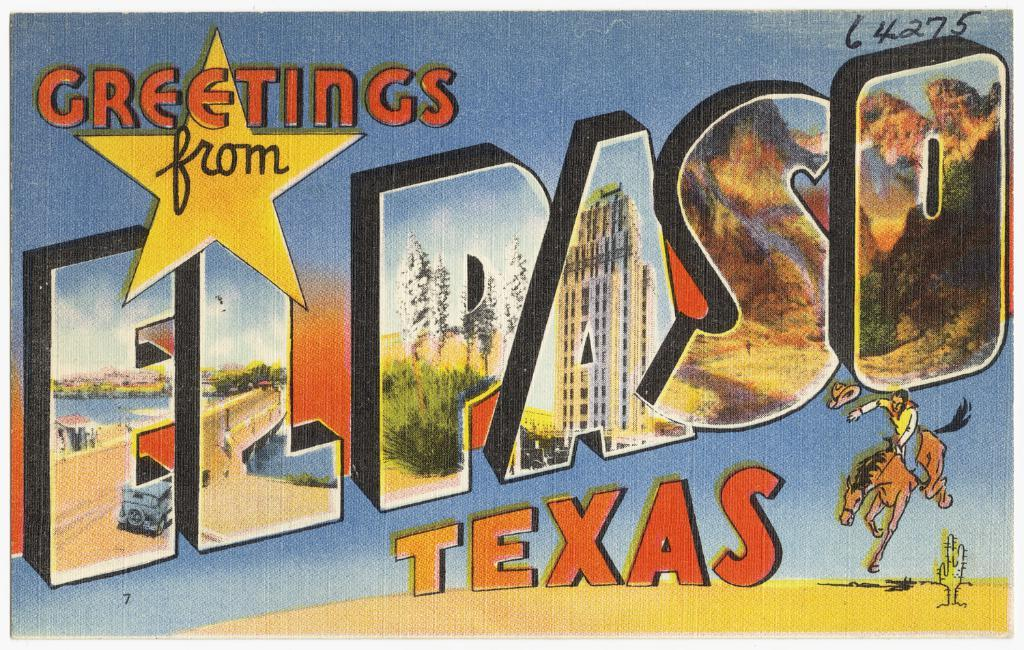<image>
Create a compact narrative representing the image presented. A postcard featuring El Paso Texas shows a cowboy on a bronco. 